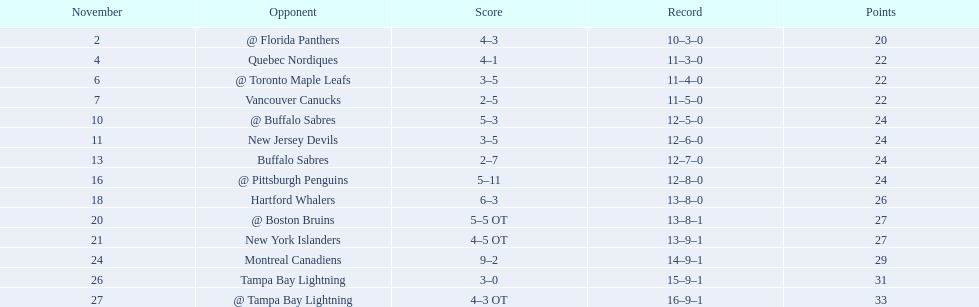The 1993-1994 flyers missed the playoffs again. how many consecutive seasons up until 93-94 did the flyers miss the playoffs? 5. 